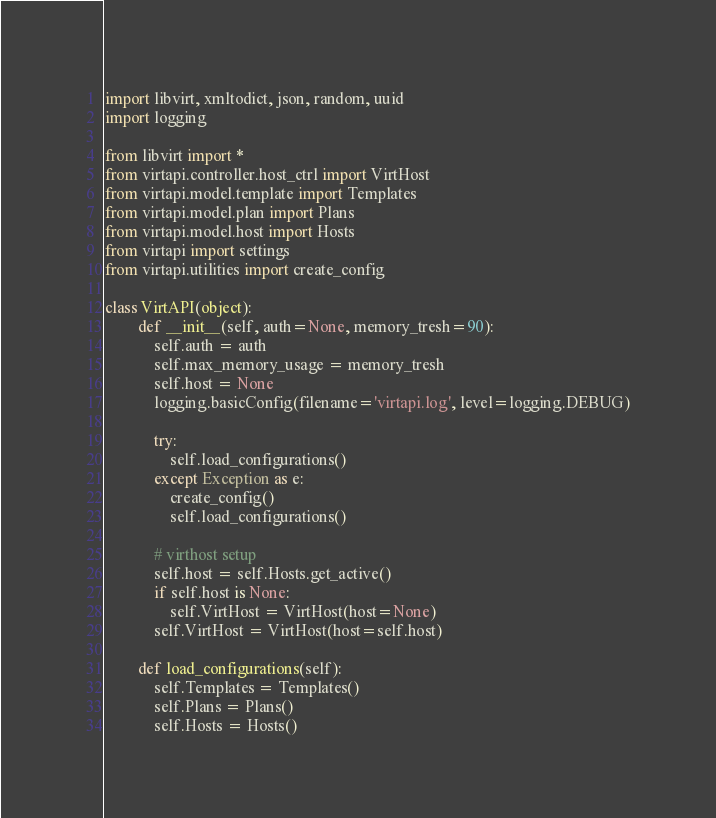Convert code to text. <code><loc_0><loc_0><loc_500><loc_500><_Python_>import libvirt, xmltodict, json, random, uuid
import logging

from libvirt import *
from virtapi.controller.host_ctrl import VirtHost
from virtapi.model.template import Templates
from virtapi.model.plan import Plans
from virtapi.model.host import Hosts
from virtapi import settings
from virtapi.utilities import create_config

class VirtAPI(object):
        def __init__(self, auth=None, memory_tresh=90):
            self.auth = auth
            self.max_memory_usage = memory_tresh
            self.host = None
            logging.basicConfig(filename='virtapi.log', level=logging.DEBUG)
            
            try:
                self.load_configurations()
            except Exception as e:
                create_config()
                self.load_configurations()

            # virthost setup
            self.host = self.Hosts.get_active()
            if self.host is None:
                self.VirtHost = VirtHost(host=None)
            self.VirtHost = VirtHost(host=self.host)

        def load_configurations(self):
            self.Templates = Templates()
            self.Plans = Plans()
            self.Hosts = Hosts()

</code> 